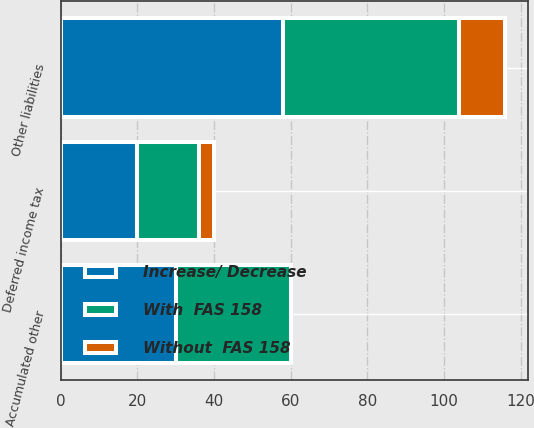Convert chart. <chart><loc_0><loc_0><loc_500><loc_500><stacked_bar_chart><ecel><fcel>Other liabilities<fcel>Deferred income tax<fcel>Accumulated other<nl><fcel>Without  FAS 158<fcel>12<fcel>4<fcel>0<nl><fcel>Increase/ Decrease<fcel>58<fcel>20<fcel>30<nl><fcel>With  FAS 158<fcel>46<fcel>16<fcel>30<nl></chart> 